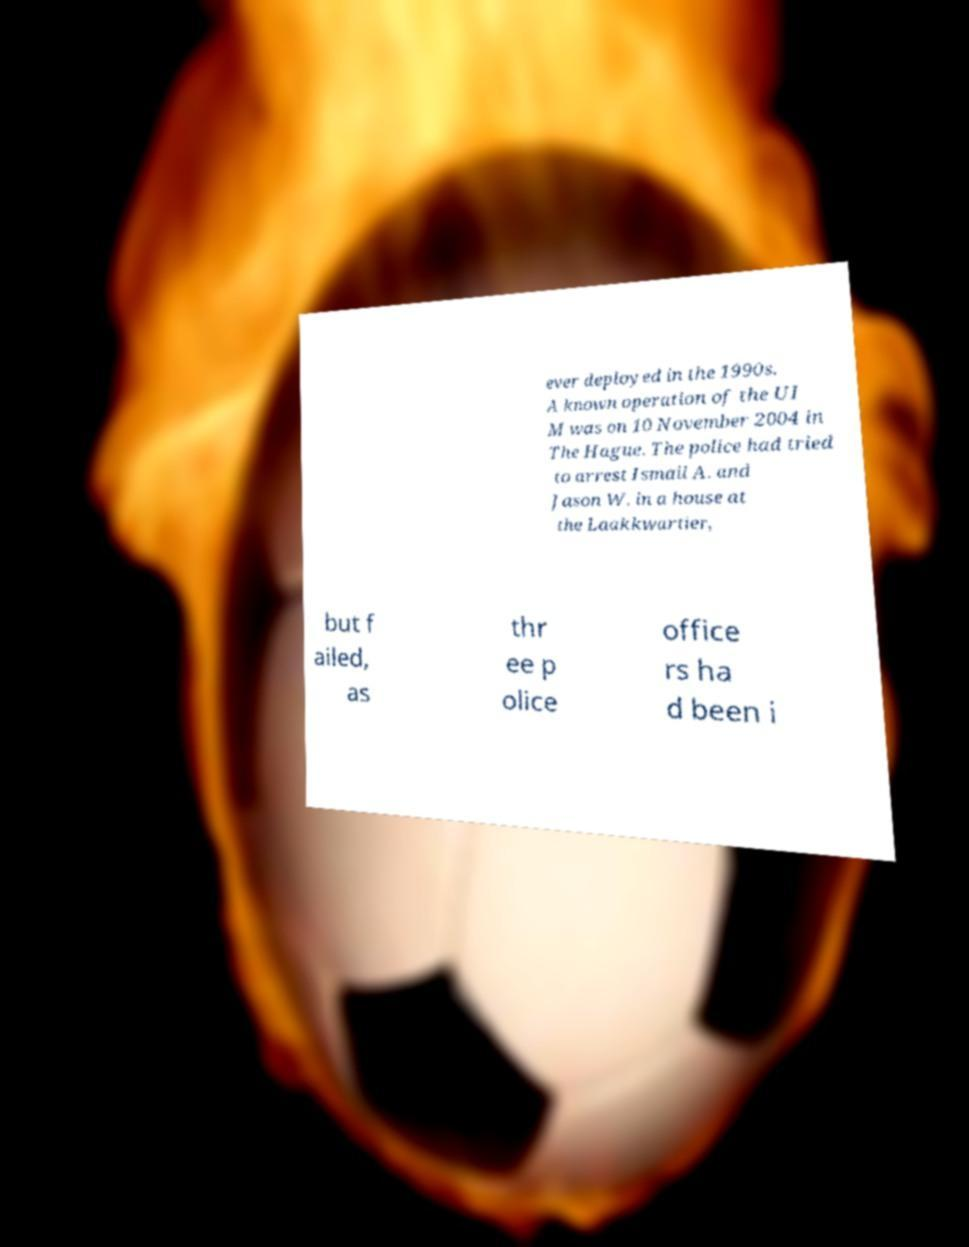Please read and relay the text visible in this image. What does it say? ever deployed in the 1990s. A known operation of the UI M was on 10 November 2004 in The Hague. The police had tried to arrest Ismail A. and Jason W. in a house at the Laakkwartier, but f ailed, as thr ee p olice office rs ha d been i 